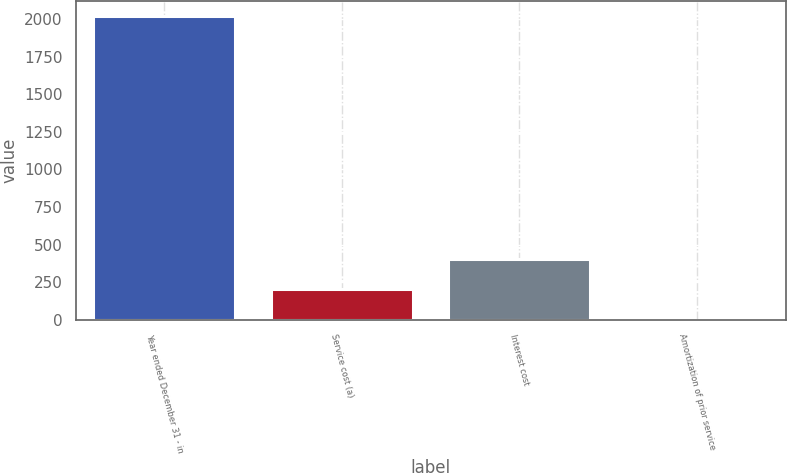<chart> <loc_0><loc_0><loc_500><loc_500><bar_chart><fcel>Year ended December 31 - in<fcel>Service cost (a)<fcel>Interest cost<fcel>Amortization of prior service<nl><fcel>2017<fcel>202.6<fcel>404.2<fcel>1<nl></chart> 